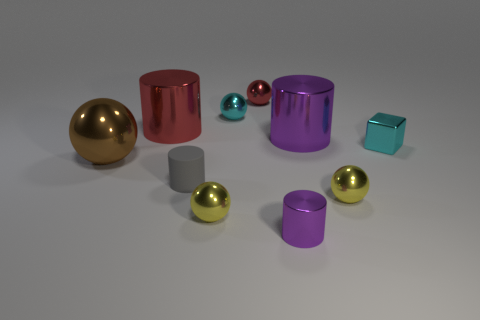There is a red metallic cylinder on the left side of the tiny red metal sphere; what size is it?
Offer a very short reply. Large. Is the size of the red object that is left of the red shiny sphere the same as the big metallic sphere?
Offer a very short reply. Yes. Is there any other thing that is the same color as the tiny metallic cylinder?
Give a very brief answer. Yes. The large brown thing is what shape?
Your answer should be very brief. Sphere. How many things are in front of the metallic block and right of the tiny red object?
Your answer should be very brief. 2. There is another small object that is the same shape as the gray matte thing; what is it made of?
Offer a very short reply. Metal. Is there anything else that has the same material as the tiny gray cylinder?
Ensure brevity in your answer.  No. Are there an equal number of brown metal balls that are behind the red metallic cylinder and cyan balls that are in front of the tiny cyan block?
Your answer should be compact. Yes. Is the material of the large brown thing the same as the small cyan cube?
Your answer should be compact. Yes. What number of brown things are either large shiny balls or small cylinders?
Your response must be concise. 1. 